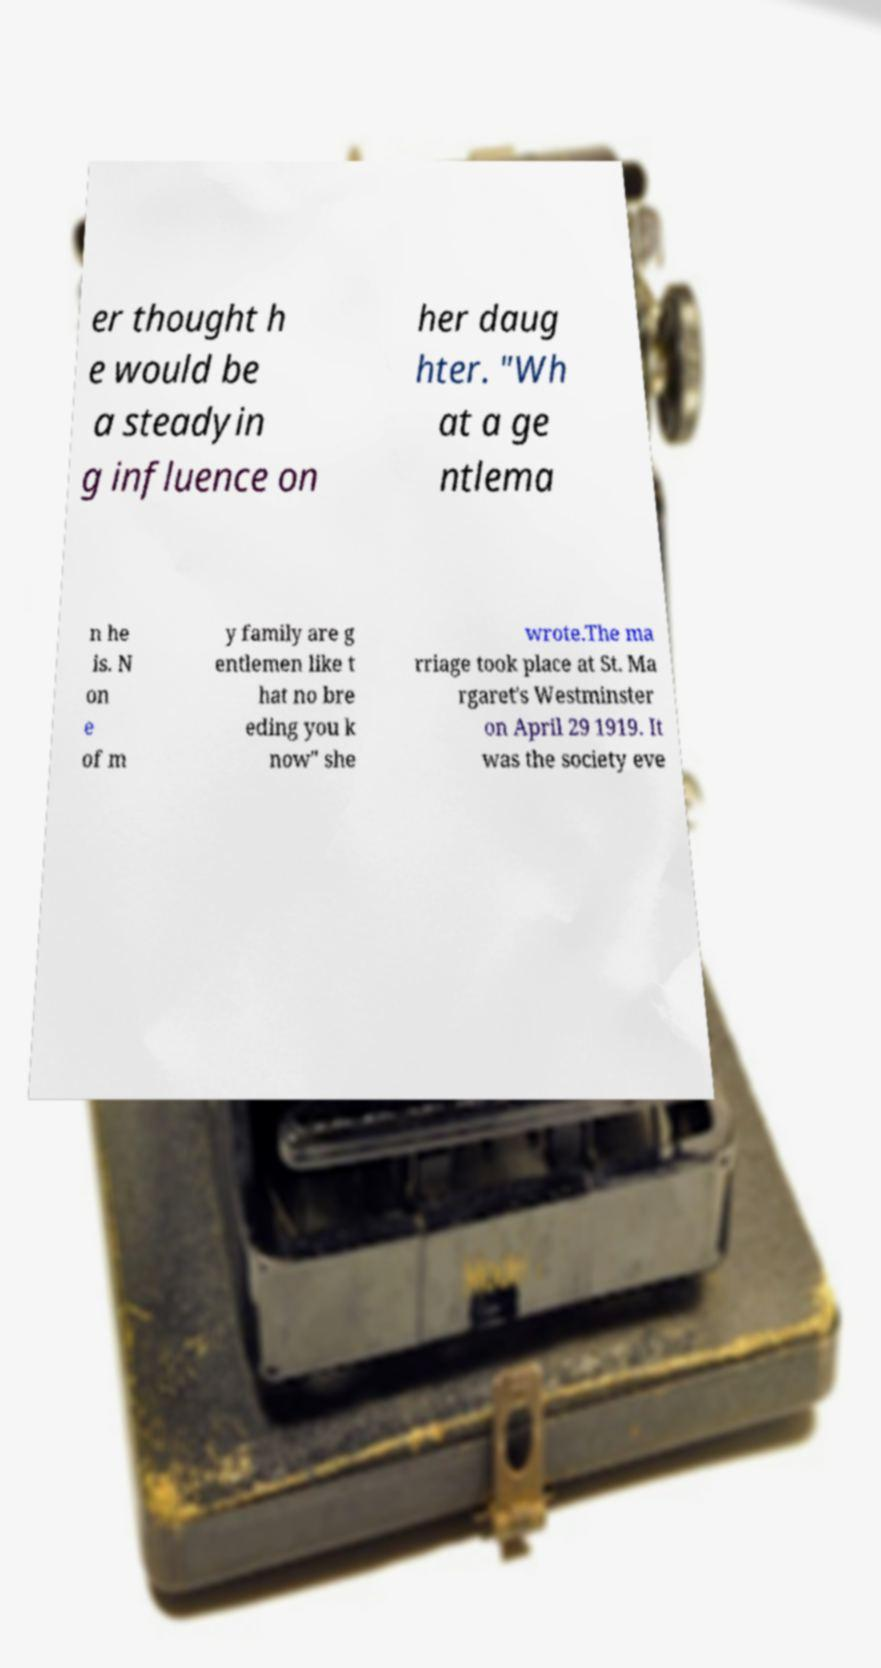What messages or text are displayed in this image? I need them in a readable, typed format. er thought h e would be a steadyin g influence on her daug hter. "Wh at a ge ntlema n he is. N on e of m y family are g entlemen like t hat no bre eding you k now" she wrote.The ma rriage took place at St. Ma rgaret's Westminster on April 29 1919. It was the society eve 